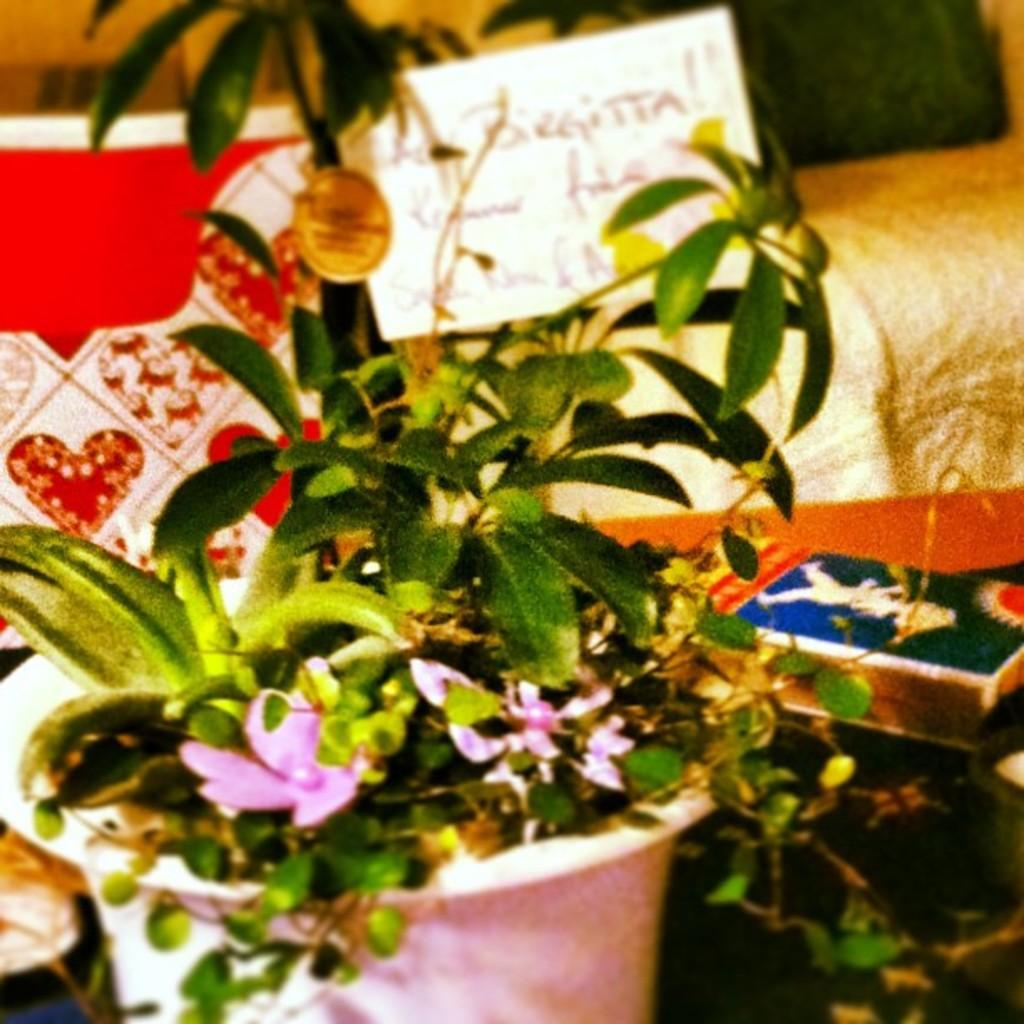What is in the pot that is visible in the image? There is a plant in the pot that is visible in the image. Can you describe the plant in the pot? The plant has leaves and flowers. What object is beside the pot in the image? There is a matchbox beside the pot. What can be seen in the background of the image? There are items visible in the background of the image. What is the name of the daughter who is pushing the plant in the image? There is no daughter present in the image, nor is anyone pushing the plant. 